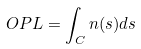<formula> <loc_0><loc_0><loc_500><loc_500>O P L = \int _ { C } n ( s ) d s</formula> 